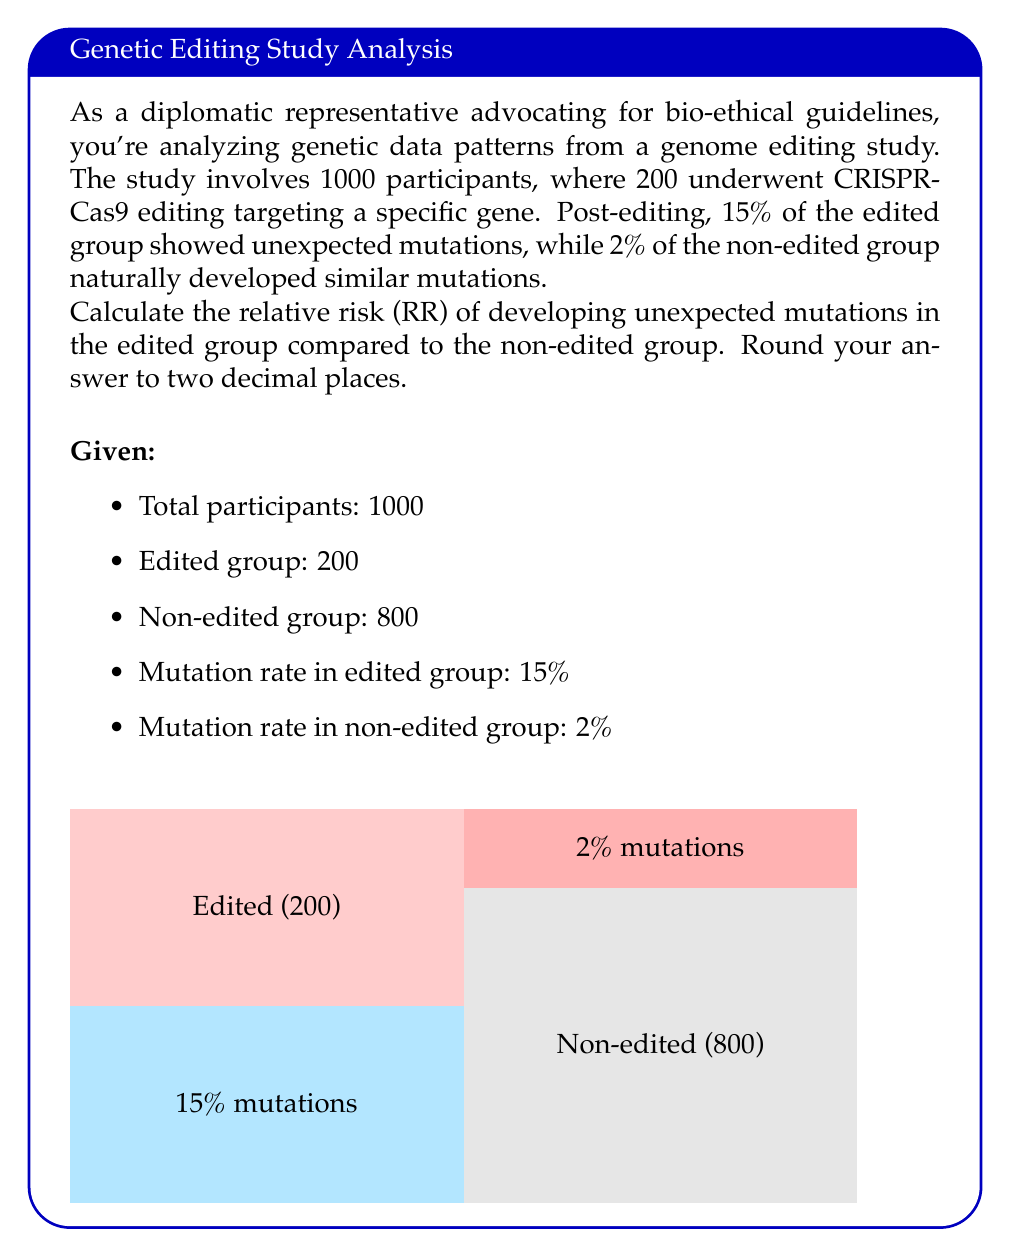Show me your answer to this math problem. To calculate the relative risk (RR), we need to follow these steps:

1) First, calculate the risk of mutations in the edited group:
   Risk in edited group = $\frac{\text{Number with mutations in edited group}}{\text{Total in edited group}}$
   $= \frac{15\% \text{ of } 200}{200} = \frac{30}{200} = 0.15$

2) Next, calculate the risk of mutations in the non-edited group:
   Risk in non-edited group = $\frac{\text{Number with mutations in non-edited group}}{\text{Total in non-edited group}}$
   $= \frac{2\% \text{ of } 800}{800} = \frac{16}{800} = 0.02$

3) The relative risk is the ratio of these two risks:
   $RR = \frac{\text{Risk in edited group}}{\text{Risk in non-edited group}}$

   $RR = \frac{0.15}{0.02} = 7.5$

4) Rounding to two decimal places:
   $RR \approx 7.50$

Therefore, the relative risk of developing unexpected mutations in the edited group compared to the non-edited group is 7.50.
Answer: 7.50 